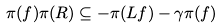<formula> <loc_0><loc_0><loc_500><loc_500>\pi ( f ) \pi ( R ) \subseteq - \pi ( L f ) - \gamma \pi ( f )</formula> 